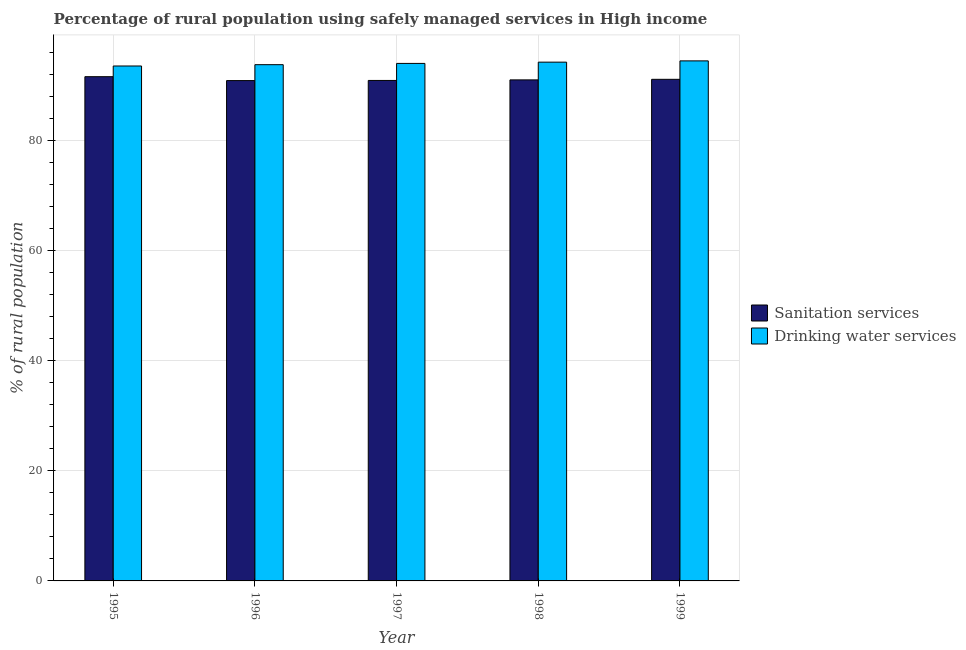How many different coloured bars are there?
Your response must be concise. 2. How many groups of bars are there?
Offer a terse response. 5. Are the number of bars on each tick of the X-axis equal?
Offer a very short reply. Yes. How many bars are there on the 5th tick from the right?
Ensure brevity in your answer.  2. In how many cases, is the number of bars for a given year not equal to the number of legend labels?
Provide a succinct answer. 0. What is the percentage of rural population who used sanitation services in 1999?
Your answer should be very brief. 91.05. Across all years, what is the maximum percentage of rural population who used drinking water services?
Ensure brevity in your answer.  94.4. Across all years, what is the minimum percentage of rural population who used drinking water services?
Give a very brief answer. 93.47. In which year was the percentage of rural population who used sanitation services maximum?
Give a very brief answer. 1995. In which year was the percentage of rural population who used drinking water services minimum?
Provide a short and direct response. 1995. What is the total percentage of rural population who used drinking water services in the graph?
Your answer should be compact. 469.68. What is the difference between the percentage of rural population who used sanitation services in 1995 and that in 1998?
Your answer should be very brief. 0.58. What is the difference between the percentage of rural population who used drinking water services in 1996 and the percentage of rural population who used sanitation services in 1999?
Offer a very short reply. -0.69. What is the average percentage of rural population who used sanitation services per year?
Ensure brevity in your answer.  91.04. In the year 1995, what is the difference between the percentage of rural population who used drinking water services and percentage of rural population who used sanitation services?
Provide a succinct answer. 0. In how many years, is the percentage of rural population who used sanitation services greater than 52 %?
Keep it short and to the point. 5. What is the ratio of the percentage of rural population who used drinking water services in 1995 to that in 1997?
Offer a very short reply. 1. Is the difference between the percentage of rural population who used drinking water services in 1998 and 1999 greater than the difference between the percentage of rural population who used sanitation services in 1998 and 1999?
Your response must be concise. No. What is the difference between the highest and the second highest percentage of rural population who used sanitation services?
Give a very brief answer. 0.48. What is the difference between the highest and the lowest percentage of rural population who used sanitation services?
Give a very brief answer. 0.71. Is the sum of the percentage of rural population who used sanitation services in 1998 and 1999 greater than the maximum percentage of rural population who used drinking water services across all years?
Your response must be concise. Yes. What does the 1st bar from the left in 1996 represents?
Ensure brevity in your answer.  Sanitation services. What does the 1st bar from the right in 1998 represents?
Your response must be concise. Drinking water services. How many years are there in the graph?
Provide a short and direct response. 5. What is the difference between two consecutive major ticks on the Y-axis?
Keep it short and to the point. 20. Are the values on the major ticks of Y-axis written in scientific E-notation?
Keep it short and to the point. No. Does the graph contain any zero values?
Offer a very short reply. No. Where does the legend appear in the graph?
Provide a short and direct response. Center right. How many legend labels are there?
Offer a very short reply. 2. What is the title of the graph?
Offer a terse response. Percentage of rural population using safely managed services in High income. Does "RDB concessional" appear as one of the legend labels in the graph?
Make the answer very short. No. What is the label or title of the Y-axis?
Provide a succinct answer. % of rural population. What is the % of rural population of Sanitation services in 1995?
Provide a short and direct response. 91.53. What is the % of rural population in Drinking water services in 1995?
Provide a short and direct response. 93.47. What is the % of rural population of Sanitation services in 1996?
Your answer should be compact. 90.82. What is the % of rural population of Drinking water services in 1996?
Offer a terse response. 93.71. What is the % of rural population of Sanitation services in 1997?
Keep it short and to the point. 90.85. What is the % of rural population in Drinking water services in 1997?
Ensure brevity in your answer.  93.94. What is the % of rural population of Sanitation services in 1998?
Your response must be concise. 90.95. What is the % of rural population of Drinking water services in 1998?
Provide a short and direct response. 94.17. What is the % of rural population in Sanitation services in 1999?
Your answer should be very brief. 91.05. What is the % of rural population in Drinking water services in 1999?
Your answer should be very brief. 94.4. Across all years, what is the maximum % of rural population in Sanitation services?
Keep it short and to the point. 91.53. Across all years, what is the maximum % of rural population in Drinking water services?
Your answer should be compact. 94.4. Across all years, what is the minimum % of rural population in Sanitation services?
Ensure brevity in your answer.  90.82. Across all years, what is the minimum % of rural population in Drinking water services?
Provide a succinct answer. 93.47. What is the total % of rural population of Sanitation services in the graph?
Keep it short and to the point. 455.2. What is the total % of rural population in Drinking water services in the graph?
Provide a short and direct response. 469.68. What is the difference between the % of rural population in Sanitation services in 1995 and that in 1996?
Make the answer very short. 0.71. What is the difference between the % of rural population in Drinking water services in 1995 and that in 1996?
Offer a very short reply. -0.24. What is the difference between the % of rural population of Sanitation services in 1995 and that in 1997?
Your answer should be very brief. 0.68. What is the difference between the % of rural population in Drinking water services in 1995 and that in 1997?
Provide a short and direct response. -0.47. What is the difference between the % of rural population of Sanitation services in 1995 and that in 1998?
Give a very brief answer. 0.58. What is the difference between the % of rural population of Drinking water services in 1995 and that in 1998?
Provide a succinct answer. -0.7. What is the difference between the % of rural population in Sanitation services in 1995 and that in 1999?
Ensure brevity in your answer.  0.48. What is the difference between the % of rural population in Drinking water services in 1995 and that in 1999?
Give a very brief answer. -0.93. What is the difference between the % of rural population of Sanitation services in 1996 and that in 1997?
Make the answer very short. -0.03. What is the difference between the % of rural population in Drinking water services in 1996 and that in 1997?
Your answer should be compact. -0.23. What is the difference between the % of rural population of Sanitation services in 1996 and that in 1998?
Ensure brevity in your answer.  -0.13. What is the difference between the % of rural population in Drinking water services in 1996 and that in 1998?
Offer a very short reply. -0.46. What is the difference between the % of rural population of Sanitation services in 1996 and that in 1999?
Your answer should be very brief. -0.23. What is the difference between the % of rural population in Drinking water services in 1996 and that in 1999?
Keep it short and to the point. -0.69. What is the difference between the % of rural population in Sanitation services in 1997 and that in 1998?
Your answer should be compact. -0.1. What is the difference between the % of rural population of Drinking water services in 1997 and that in 1998?
Give a very brief answer. -0.23. What is the difference between the % of rural population in Sanitation services in 1997 and that in 1999?
Provide a short and direct response. -0.21. What is the difference between the % of rural population of Drinking water services in 1997 and that in 1999?
Offer a terse response. -0.46. What is the difference between the % of rural population of Sanitation services in 1998 and that in 1999?
Offer a terse response. -0.1. What is the difference between the % of rural population in Drinking water services in 1998 and that in 1999?
Provide a succinct answer. -0.23. What is the difference between the % of rural population of Sanitation services in 1995 and the % of rural population of Drinking water services in 1996?
Provide a succinct answer. -2.18. What is the difference between the % of rural population in Sanitation services in 1995 and the % of rural population in Drinking water services in 1997?
Provide a succinct answer. -2.41. What is the difference between the % of rural population of Sanitation services in 1995 and the % of rural population of Drinking water services in 1998?
Your answer should be very brief. -2.64. What is the difference between the % of rural population of Sanitation services in 1995 and the % of rural population of Drinking water services in 1999?
Ensure brevity in your answer.  -2.87. What is the difference between the % of rural population of Sanitation services in 1996 and the % of rural population of Drinking water services in 1997?
Your response must be concise. -3.12. What is the difference between the % of rural population of Sanitation services in 1996 and the % of rural population of Drinking water services in 1998?
Keep it short and to the point. -3.35. What is the difference between the % of rural population of Sanitation services in 1996 and the % of rural population of Drinking water services in 1999?
Keep it short and to the point. -3.58. What is the difference between the % of rural population of Sanitation services in 1997 and the % of rural population of Drinking water services in 1998?
Offer a very short reply. -3.32. What is the difference between the % of rural population of Sanitation services in 1997 and the % of rural population of Drinking water services in 1999?
Your response must be concise. -3.55. What is the difference between the % of rural population of Sanitation services in 1998 and the % of rural population of Drinking water services in 1999?
Ensure brevity in your answer.  -3.45. What is the average % of rural population of Sanitation services per year?
Provide a short and direct response. 91.04. What is the average % of rural population of Drinking water services per year?
Keep it short and to the point. 93.94. In the year 1995, what is the difference between the % of rural population in Sanitation services and % of rural population in Drinking water services?
Your answer should be compact. -1.94. In the year 1996, what is the difference between the % of rural population of Sanitation services and % of rural population of Drinking water services?
Offer a terse response. -2.89. In the year 1997, what is the difference between the % of rural population in Sanitation services and % of rural population in Drinking water services?
Keep it short and to the point. -3.09. In the year 1998, what is the difference between the % of rural population in Sanitation services and % of rural population in Drinking water services?
Your response must be concise. -3.22. In the year 1999, what is the difference between the % of rural population of Sanitation services and % of rural population of Drinking water services?
Ensure brevity in your answer.  -3.35. What is the ratio of the % of rural population in Sanitation services in 1995 to that in 1996?
Keep it short and to the point. 1.01. What is the ratio of the % of rural population of Drinking water services in 1995 to that in 1996?
Your answer should be very brief. 1. What is the ratio of the % of rural population in Sanitation services in 1995 to that in 1997?
Offer a terse response. 1.01. What is the ratio of the % of rural population in Drinking water services in 1995 to that in 1997?
Your answer should be compact. 0.99. What is the ratio of the % of rural population in Sanitation services in 1995 to that in 1998?
Your response must be concise. 1.01. What is the ratio of the % of rural population of Drinking water services in 1995 to that in 1998?
Keep it short and to the point. 0.99. What is the ratio of the % of rural population in Drinking water services in 1995 to that in 1999?
Your answer should be very brief. 0.99. What is the ratio of the % of rural population in Sanitation services in 1996 to that in 1997?
Keep it short and to the point. 1. What is the ratio of the % of rural population in Drinking water services in 1996 to that in 1997?
Make the answer very short. 1. What is the ratio of the % of rural population of Sanitation services in 1996 to that in 1998?
Offer a very short reply. 1. What is the ratio of the % of rural population in Drinking water services in 1996 to that in 1998?
Offer a terse response. 1. What is the ratio of the % of rural population of Sanitation services in 1996 to that in 1999?
Make the answer very short. 1. What is the ratio of the % of rural population in Drinking water services in 1997 to that in 1998?
Your response must be concise. 1. What is the ratio of the % of rural population in Drinking water services in 1998 to that in 1999?
Ensure brevity in your answer.  1. What is the difference between the highest and the second highest % of rural population of Sanitation services?
Ensure brevity in your answer.  0.48. What is the difference between the highest and the second highest % of rural population of Drinking water services?
Make the answer very short. 0.23. What is the difference between the highest and the lowest % of rural population of Sanitation services?
Your answer should be very brief. 0.71. What is the difference between the highest and the lowest % of rural population of Drinking water services?
Give a very brief answer. 0.93. 